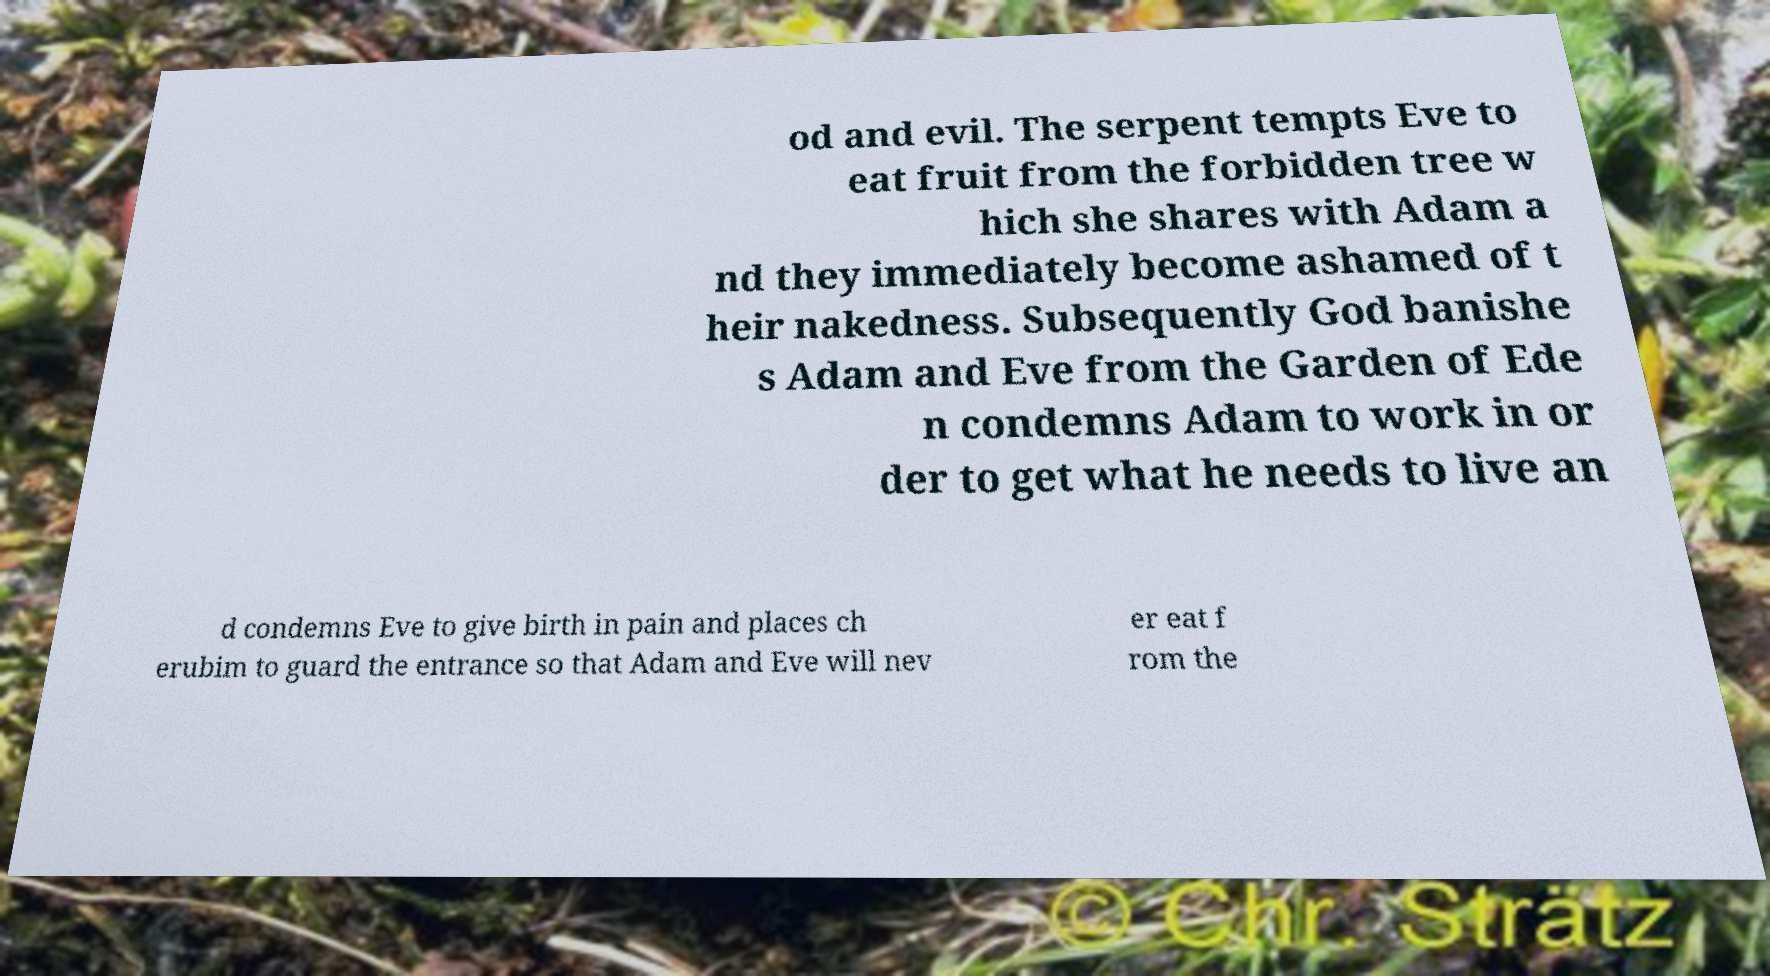I need the written content from this picture converted into text. Can you do that? od and evil. The serpent tempts Eve to eat fruit from the forbidden tree w hich she shares with Adam a nd they immediately become ashamed of t heir nakedness. Subsequently God banishe s Adam and Eve from the Garden of Ede n condemns Adam to work in or der to get what he needs to live an d condemns Eve to give birth in pain and places ch erubim to guard the entrance so that Adam and Eve will nev er eat f rom the 